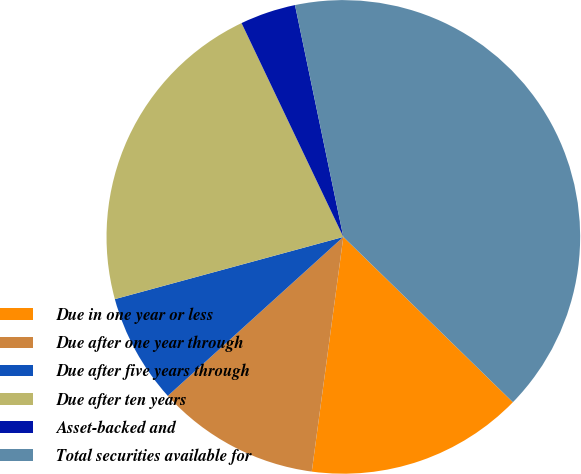Convert chart to OTSL. <chart><loc_0><loc_0><loc_500><loc_500><pie_chart><fcel>Due in one year or less<fcel>Due after one year through<fcel>Due after five years through<fcel>Due after ten years<fcel>Asset-backed and<fcel>Total securities available for<nl><fcel>14.83%<fcel>11.16%<fcel>7.48%<fcel>22.16%<fcel>3.8%<fcel>40.57%<nl></chart> 